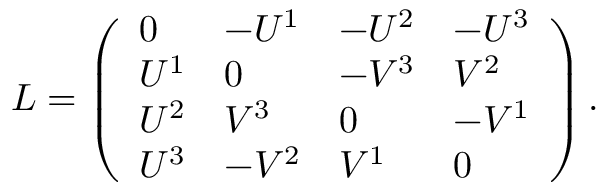<formula> <loc_0><loc_0><loc_500><loc_500>L = \left ( \begin{array} { l l l l } { 0 } & { - U ^ { 1 } } & { - U ^ { 2 } } & { - U ^ { 3 } } \\ { U ^ { 1 } } & { 0 } & { - V ^ { 3 } } & { V ^ { 2 } } \\ { U ^ { 2 } } & { V ^ { 3 } } & { 0 } & { - V ^ { 1 } } \\ { U ^ { 3 } } & { - V ^ { 2 } } & { V ^ { 1 } } & { 0 } \end{array} \right ) .</formula> 